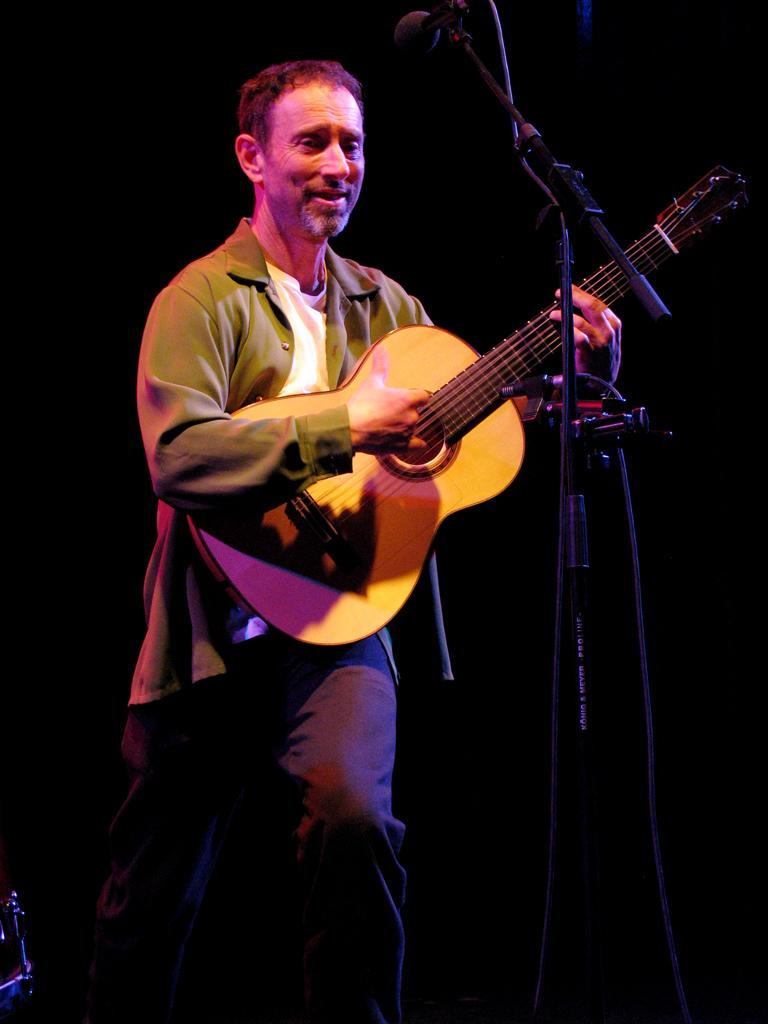What is the man in the image doing? The man is playing a guitar. What is the man wearing on his upper body? The man is wearing a green jacket and a white t-shirt. What is the man wearing on his lower body? The man is wearing black trousers. What object is in front of the man? There is a microphone in front of the man. How would you describe the lighting in the image? The background of the image is dark. What type of experience does the man have with sleep in the image? There is no information about the man's experience with sleep in the image. Is there any evidence of a currency exchange happening in the image? There is no mention of currency exchange or any related activity in the image. 